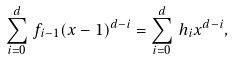<formula> <loc_0><loc_0><loc_500><loc_500>\sum _ { i = 0 } ^ { d } \, f _ { i - 1 } ( x - 1 ) ^ { d - i } = \sum _ { i = 0 } ^ { d } \, h _ { i } x ^ { d - i } ,</formula> 